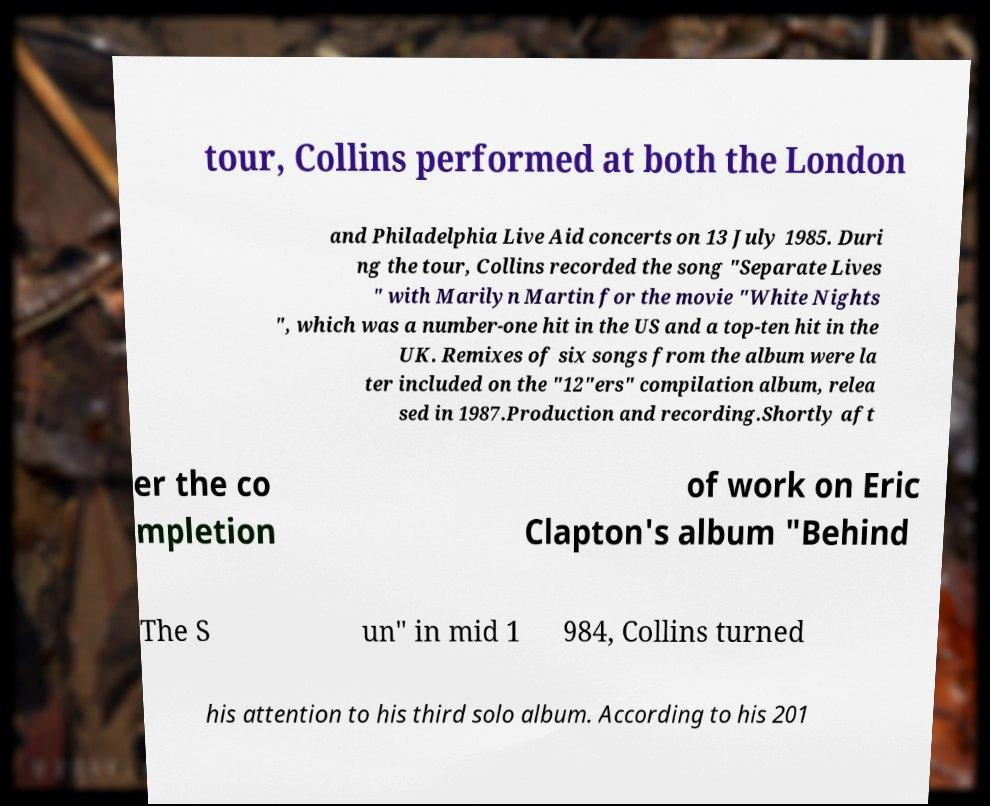Can you read and provide the text displayed in the image?This photo seems to have some interesting text. Can you extract and type it out for me? tour, Collins performed at both the London and Philadelphia Live Aid concerts on 13 July 1985. Duri ng the tour, Collins recorded the song "Separate Lives " with Marilyn Martin for the movie "White Nights ", which was a number-one hit in the US and a top-ten hit in the UK. Remixes of six songs from the album were la ter included on the "12"ers" compilation album, relea sed in 1987.Production and recording.Shortly aft er the co mpletion of work on Eric Clapton's album "Behind The S un" in mid 1 984, Collins turned his attention to his third solo album. According to his 201 